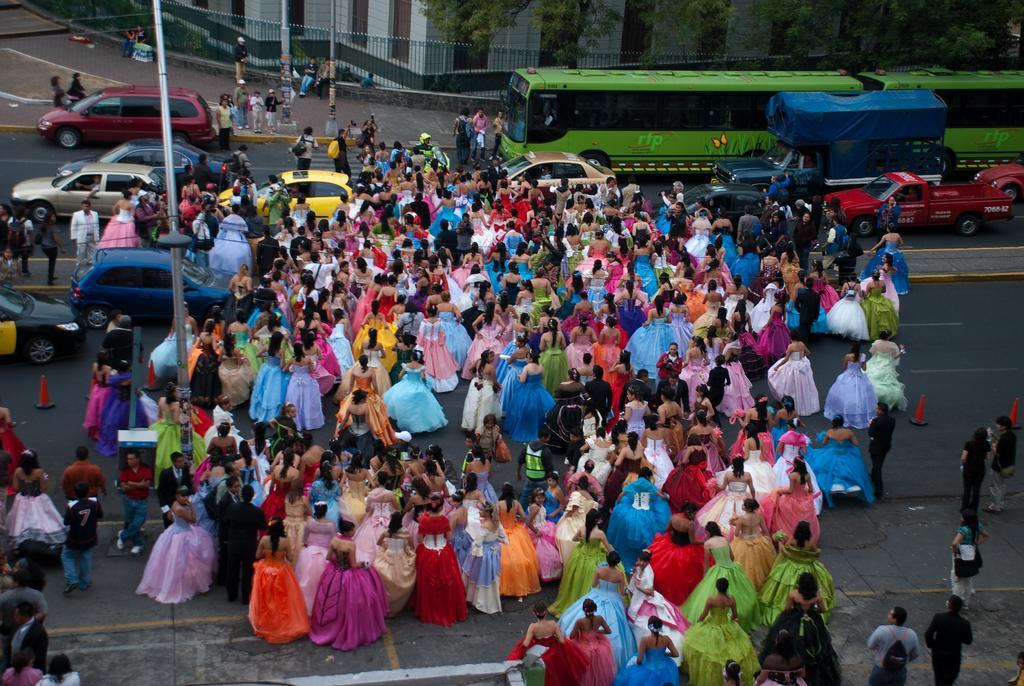How would you summarize this image in a sentence or two? In this image, we can see a crowd crossing the road. There is a pole on the left side of the image. There are some vehicles on the road. There is a fencing and branch in front of the building which is at the top of the image. 